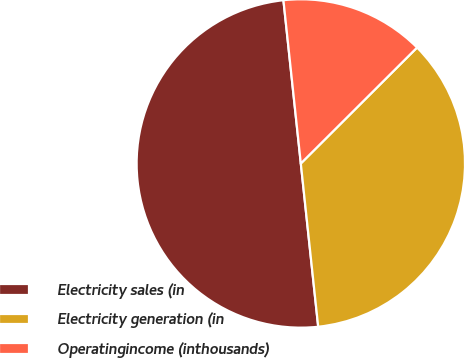Convert chart. <chart><loc_0><loc_0><loc_500><loc_500><pie_chart><fcel>Electricity sales (in<fcel>Electricity generation (in<fcel>Operatingincome (inthousands)<nl><fcel>50.0%<fcel>35.79%<fcel>14.21%<nl></chart> 